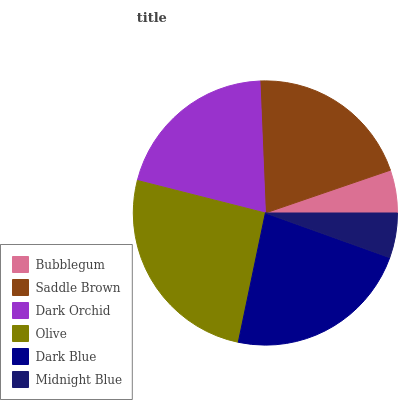Is Bubblegum the minimum?
Answer yes or no. Yes. Is Olive the maximum?
Answer yes or no. Yes. Is Saddle Brown the minimum?
Answer yes or no. No. Is Saddle Brown the maximum?
Answer yes or no. No. Is Saddle Brown greater than Bubblegum?
Answer yes or no. Yes. Is Bubblegum less than Saddle Brown?
Answer yes or no. Yes. Is Bubblegum greater than Saddle Brown?
Answer yes or no. No. Is Saddle Brown less than Bubblegum?
Answer yes or no. No. Is Saddle Brown the high median?
Answer yes or no. Yes. Is Dark Orchid the low median?
Answer yes or no. Yes. Is Dark Orchid the high median?
Answer yes or no. No. Is Saddle Brown the low median?
Answer yes or no. No. 